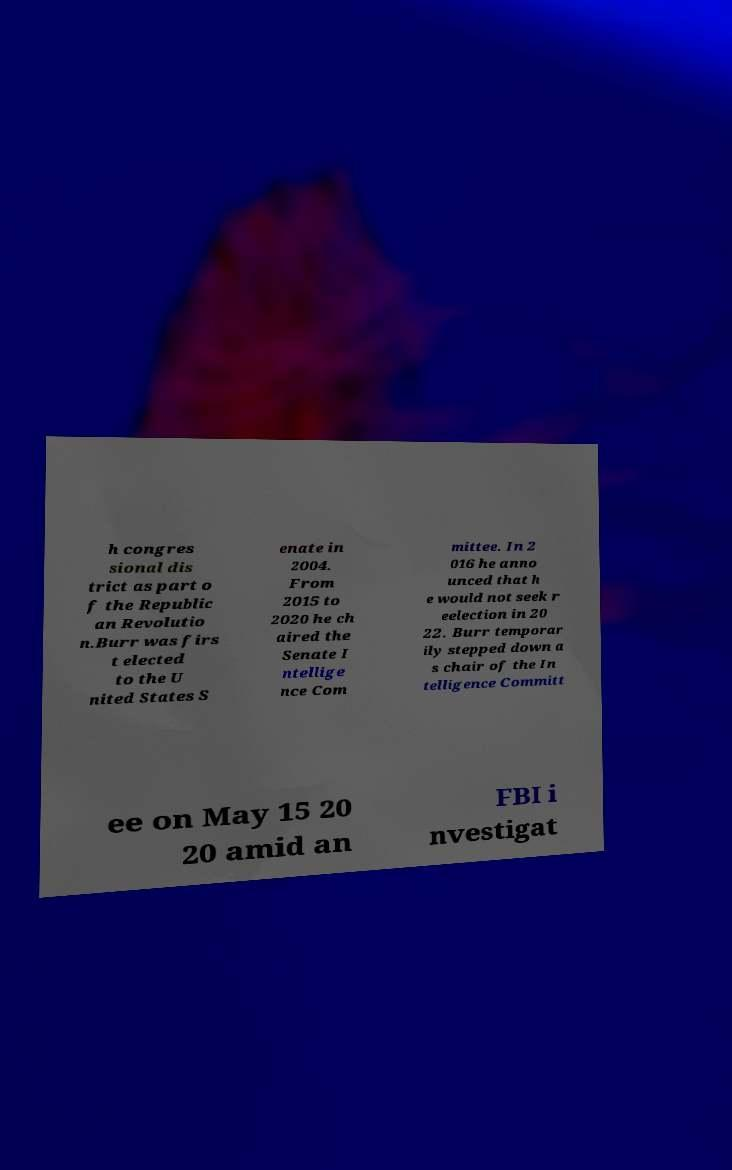Please identify and transcribe the text found in this image. h congres sional dis trict as part o f the Republic an Revolutio n.Burr was firs t elected to the U nited States S enate in 2004. From 2015 to 2020 he ch aired the Senate I ntellige nce Com mittee. In 2 016 he anno unced that h e would not seek r eelection in 20 22. Burr temporar ily stepped down a s chair of the In telligence Committ ee on May 15 20 20 amid an FBI i nvestigat 